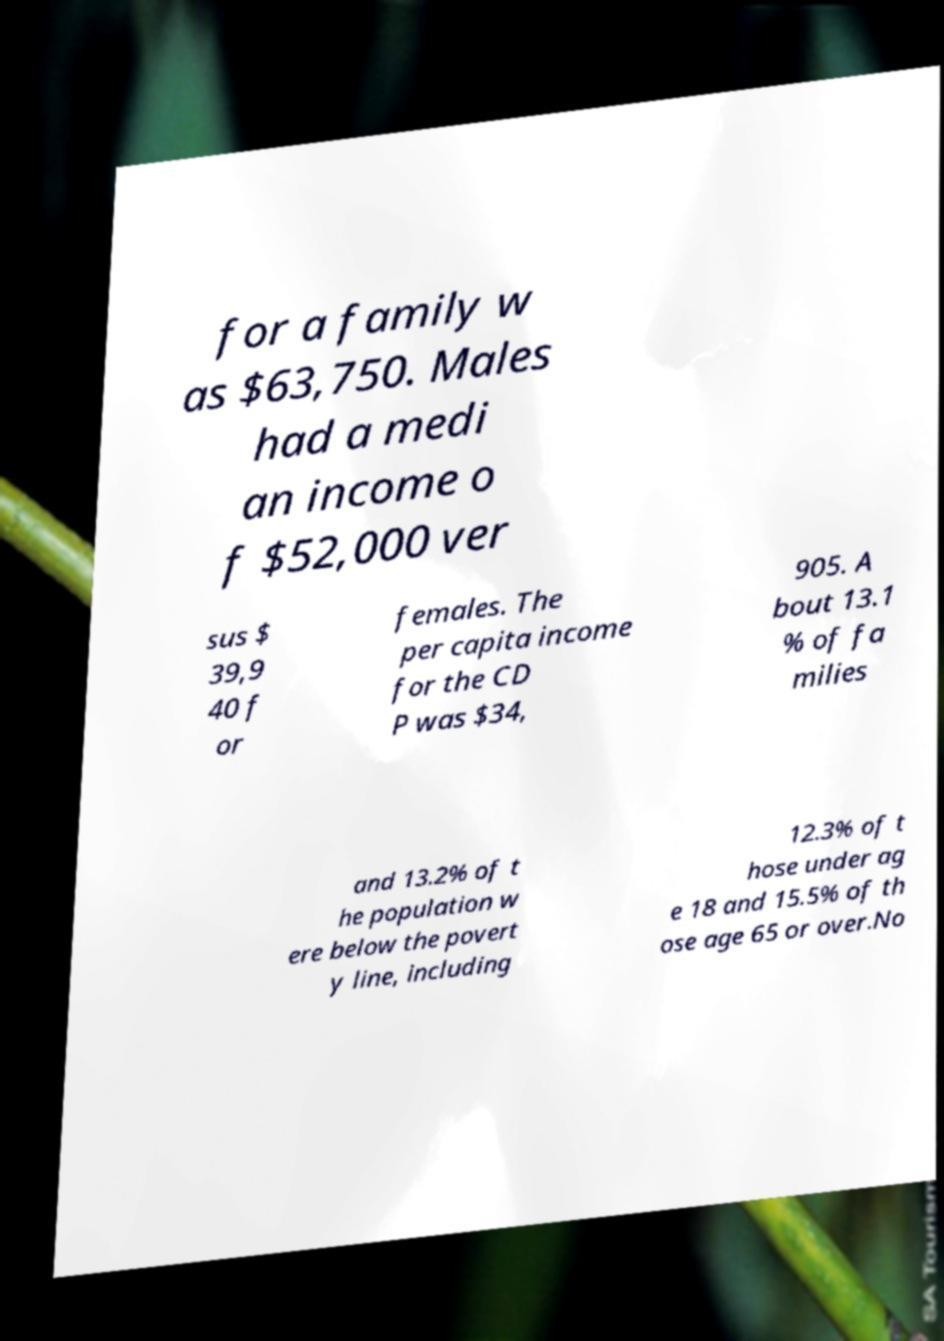I need the written content from this picture converted into text. Can you do that? for a family w as $63,750. Males had a medi an income o f $52,000 ver sus $ 39,9 40 f or females. The per capita income for the CD P was $34, 905. A bout 13.1 % of fa milies and 13.2% of t he population w ere below the povert y line, including 12.3% of t hose under ag e 18 and 15.5% of th ose age 65 or over.No 